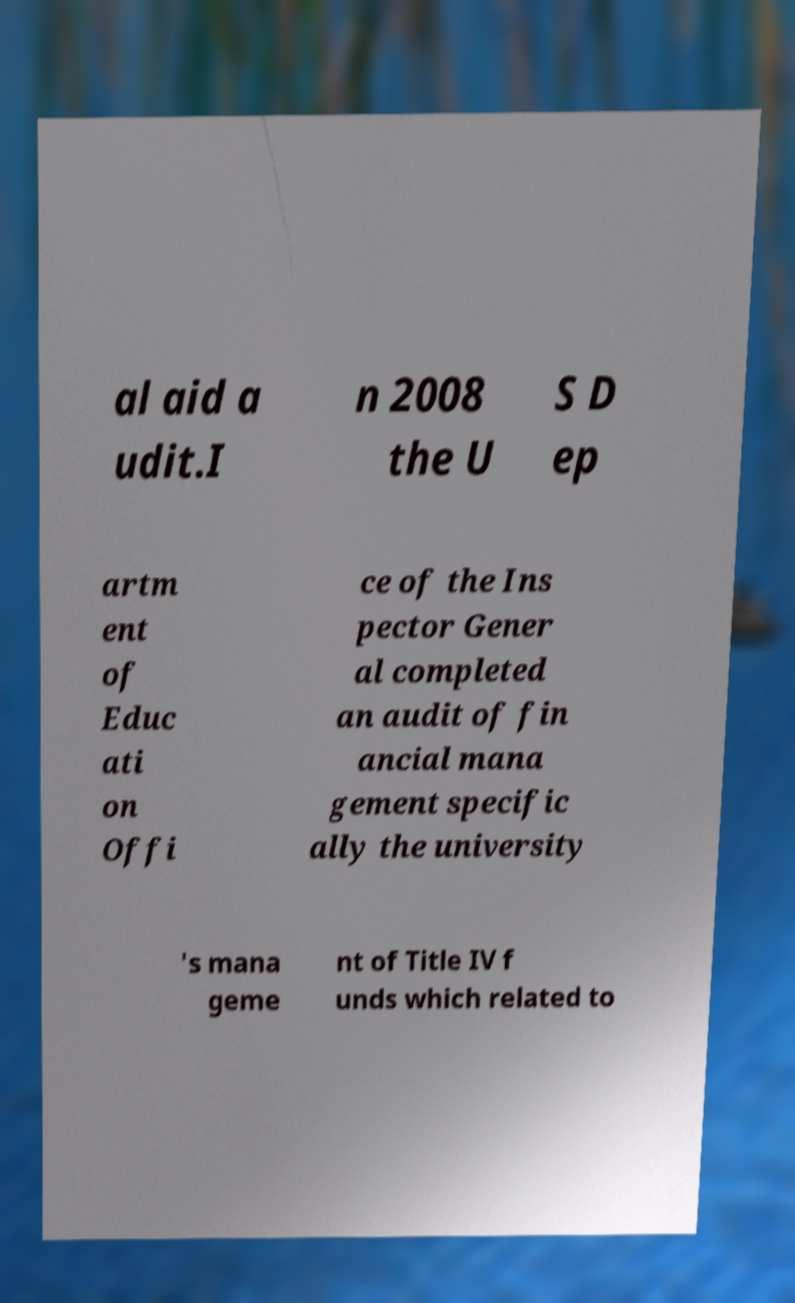Please identify and transcribe the text found in this image. al aid a udit.I n 2008 the U S D ep artm ent of Educ ati on Offi ce of the Ins pector Gener al completed an audit of fin ancial mana gement specific ally the university 's mana geme nt of Title IV f unds which related to 